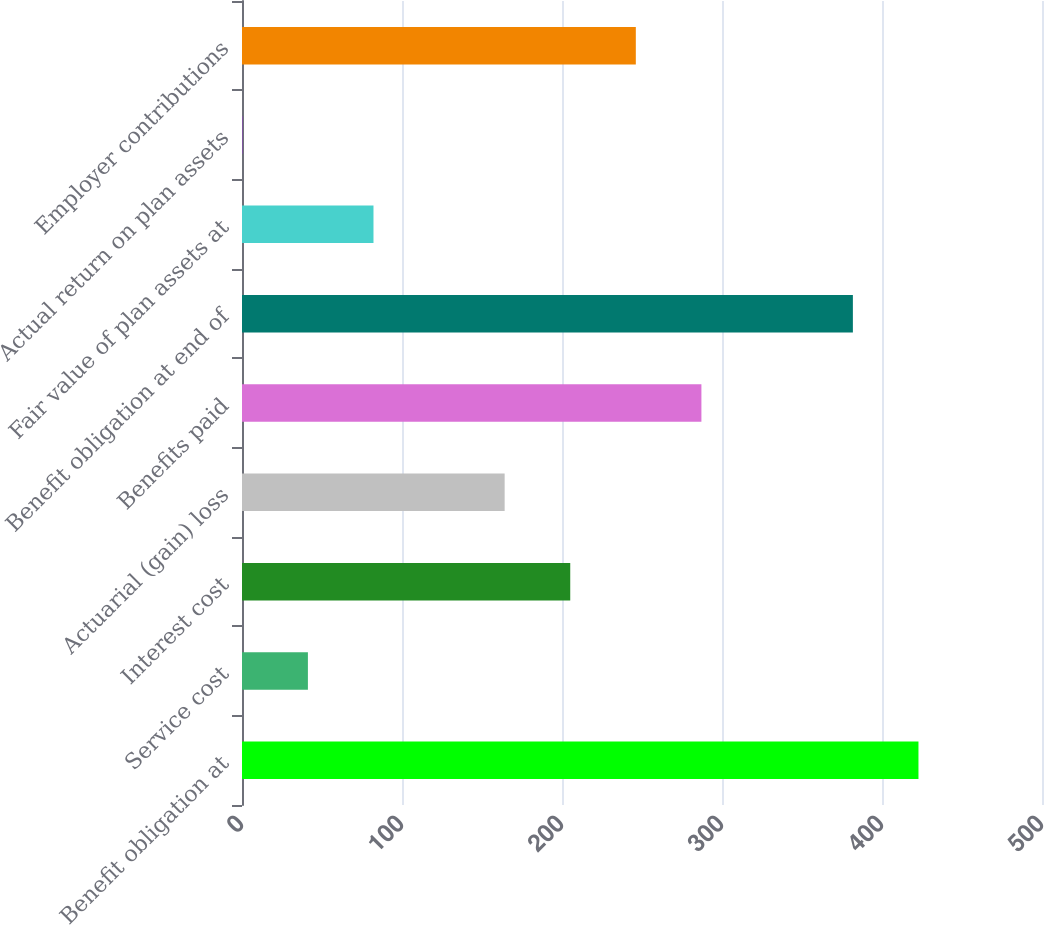Convert chart to OTSL. <chart><loc_0><loc_0><loc_500><loc_500><bar_chart><fcel>Benefit obligation at<fcel>Service cost<fcel>Interest cost<fcel>Actuarial (gain) loss<fcel>Benefits paid<fcel>Benefit obligation at end of<fcel>Fair value of plan assets at<fcel>Actual return on plan assets<fcel>Employer contributions<nl><fcel>422.79<fcel>41.19<fcel>205.15<fcel>164.16<fcel>287.13<fcel>381.8<fcel>82.18<fcel>0.2<fcel>246.14<nl></chart> 